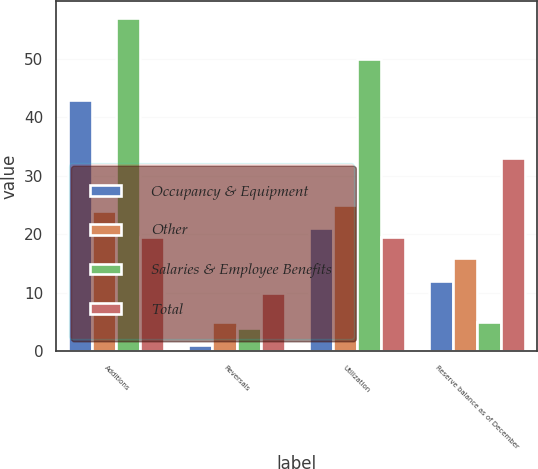Convert chart. <chart><loc_0><loc_0><loc_500><loc_500><stacked_bar_chart><ecel><fcel>Additions<fcel>Reversals<fcel>Utilization<fcel>Reserve balance as of December<nl><fcel>Occupancy & Equipment<fcel>43<fcel>1<fcel>21<fcel>12<nl><fcel>Other<fcel>24<fcel>5<fcel>25<fcel>16<nl><fcel>Salaries & Employee Benefits<fcel>57<fcel>4<fcel>50<fcel>5<nl><fcel>Total<fcel>19.5<fcel>10<fcel>19.5<fcel>33<nl></chart> 